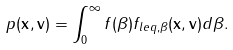Convert formula to latex. <formula><loc_0><loc_0><loc_500><loc_500>p ( \mathbf x , \mathbf v ) = \int _ { 0 } ^ { \infty } f ( \beta ) f _ { l e q , \beta } ( \mathbf x , \mathbf v ) d \beta .</formula> 